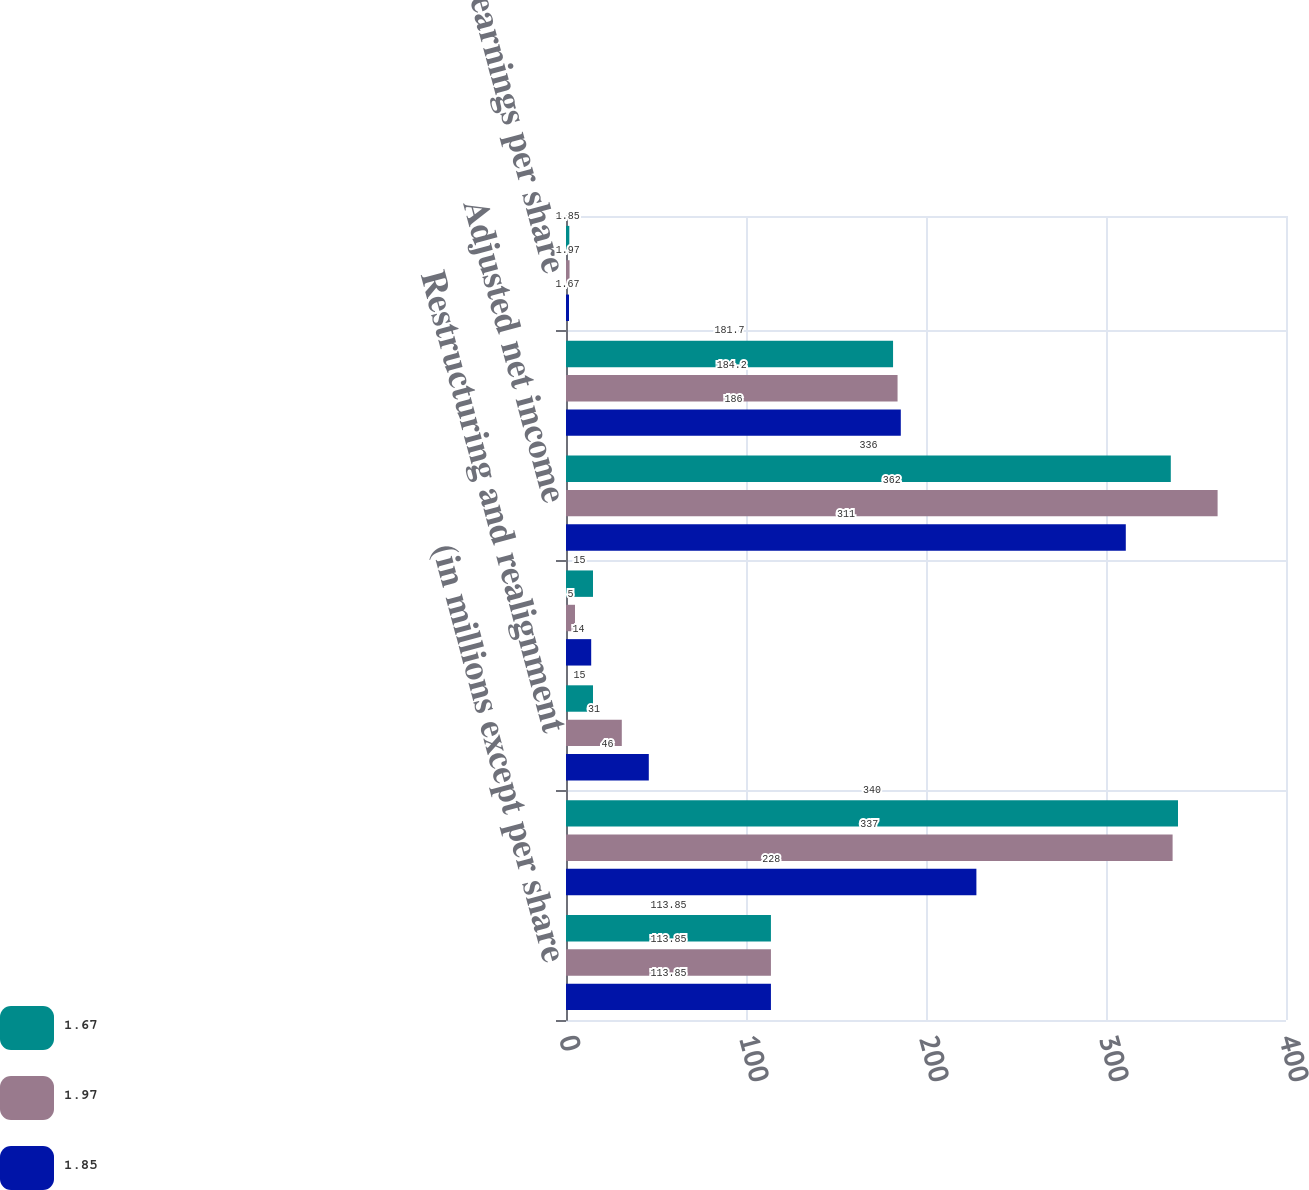<chart> <loc_0><loc_0><loc_500><loc_500><stacked_bar_chart><ecel><fcel>(in millions except per share<fcel>Net income<fcel>Restructuring and realignment<fcel>Tax-related special items<fcel>Adjusted net income<fcel>Weighted average number of<fcel>Adjusted earnings per share<nl><fcel>1.67<fcel>113.85<fcel>340<fcel>15<fcel>15<fcel>336<fcel>181.7<fcel>1.85<nl><fcel>1.97<fcel>113.85<fcel>337<fcel>31<fcel>5<fcel>362<fcel>184.2<fcel>1.97<nl><fcel>1.85<fcel>113.85<fcel>228<fcel>46<fcel>14<fcel>311<fcel>186<fcel>1.67<nl></chart> 